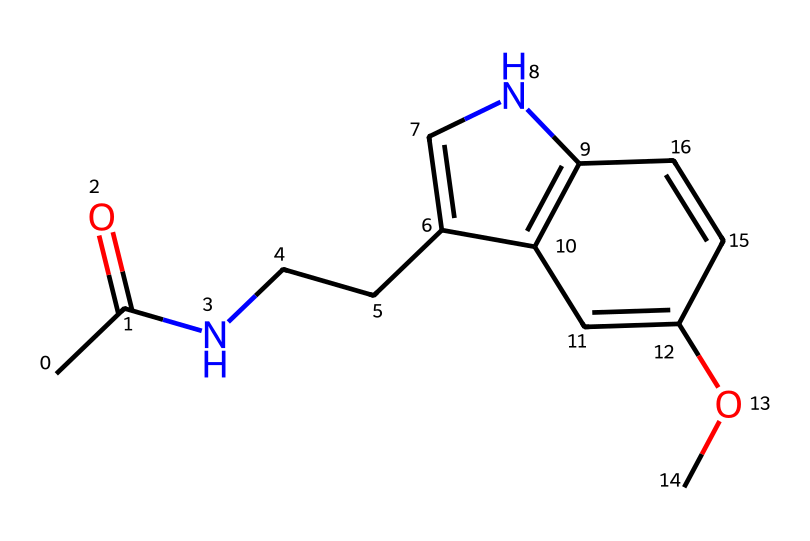What is the main functional group in melatonin? The main functional group in melatonin is an amide (due to the presence of a carbonyl group directly attached to a nitrogen atom), which is indicated in the structure by the CC(=O)N portion.
Answer: amide How many carbon atoms are present in melatonin? By counting the carbon atoms in the SMILES representation, there are 13 carbon atoms in total. The structural formula can help visualize each carbon in the molecule.
Answer: 13 What type of hormone is melatonin classified as? Melatonin is classified as a neurohormone because it is produced in the brain's pineal gland and regulates sleep-wake cycles. This classification is determined based on its synthesis and function.
Answer: neurohormone Which part of melatonin is responsible for sleep regulation? The indoleamine structure (the indole ring system present in the chemical) is primarily responsible for its role in sleep regulation due to its interaction with melatonin receptors.
Answer: indoleamine How does melatonin affect pediatric sleep patterns? Melatonin encourages sleep onset, helping to regulate circadian rhythms in children, especially in cases of sleep disorders, by binding to specific receptors.
Answer: promotes sleep What is the molecular formula of melatonin? To determine the molecular formula from the SMILES, we can count the atoms represented: C13, H16, N2, O2. Therefore, the molecular formula is C13H16N2O2.
Answer: C13H16N2O2 What role does the methoxy group play in melatonin? The methoxy group (OC) contributes to the molecule's lipophilicity, enhancing its ability to cross cell membranes and reach melatonin receptors.
Answer: lipophilicity 